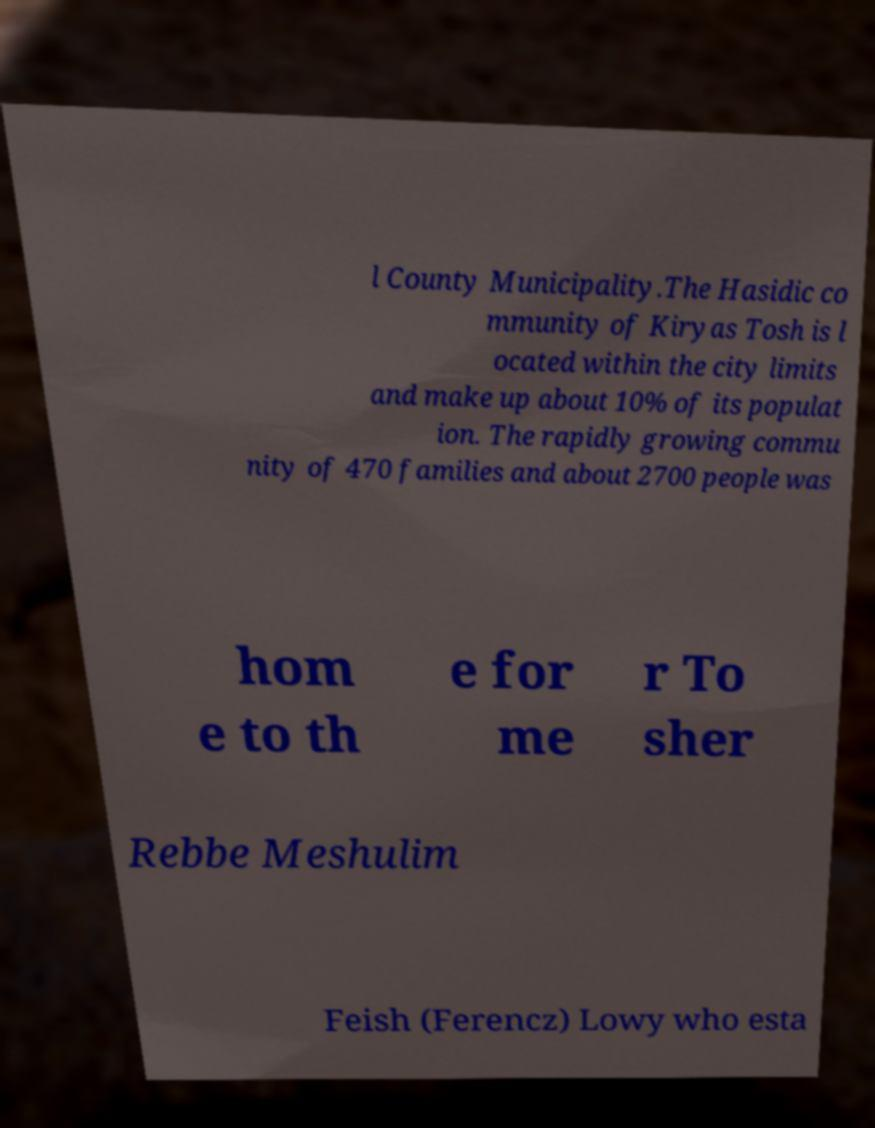Can you read and provide the text displayed in the image?This photo seems to have some interesting text. Can you extract and type it out for me? l County Municipality.The Hasidic co mmunity of Kiryas Tosh is l ocated within the city limits and make up about 10% of its populat ion. The rapidly growing commu nity of 470 families and about 2700 people was hom e to th e for me r To sher Rebbe Meshulim Feish (Ferencz) Lowy who esta 